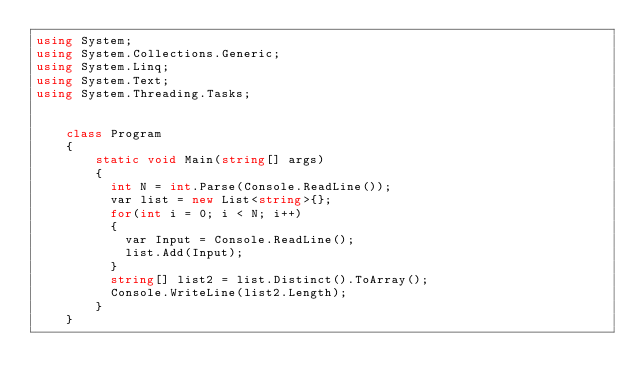<code> <loc_0><loc_0><loc_500><loc_500><_C#_>using System;
using System.Collections.Generic;
using System.Linq;
using System.Text;
using System.Threading.Tasks;


    class Program
    {
        static void Main(string[] args)
        {
          int N = int.Parse(Console.ReadLine());
          var list = new List<string>{};
          for(int i = 0; i < N; i++)
          {
            var Input = Console.ReadLine();
            list.Add(Input);
          }
          string[] list2 = list.Distinct().ToArray();
          Console.WriteLine(list2.Length);
        }
    }</code> 